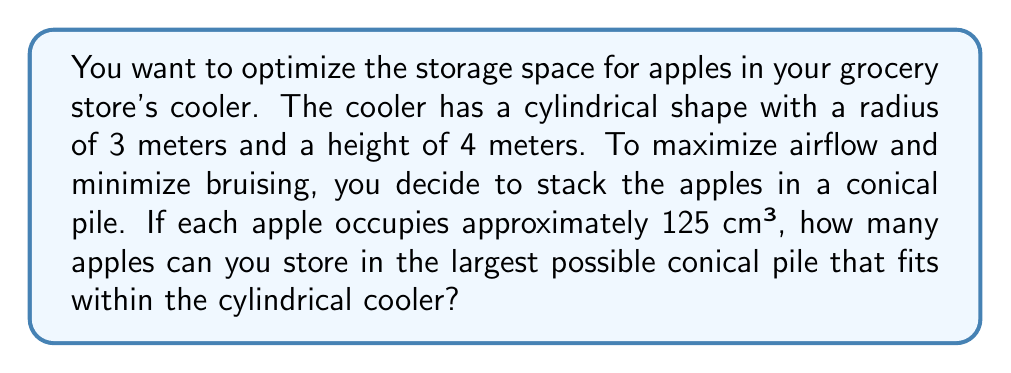Teach me how to tackle this problem. Let's approach this step-by-step:

1) First, we need to determine the dimensions of the largest cone that fits inside the cylinder. The cone's base radius will be equal to the cylinder's radius (3 m), and its height will be equal to the cylinder's height (4 m).

2) The volume of a cone is given by the formula:

   $$V_{cone} = \frac{1}{3}\pi r^2 h$$

   where $r$ is the radius of the base and $h$ is the height.

3) Substituting our values:

   $$V_{cone} = \frac{1}{3}\pi (3\,m)^2 (4\,m) = \frac{4}{3}\pi (9\,m^3) = 12\pi\,m^3$$

4) We need to convert this to cm³:

   $$12\pi\,m^3 = 12\pi \times (100\,cm)^3 = 12,000,000\pi\,cm^3$$

5) Now, we divide this volume by the volume of each apple (125 cm³):

   $$\text{Number of apples} = \frac{12,000,000\pi\,cm^3}{125\,cm^3} = 96,000\pi$$

6) Since we can't have a fractional apple, we need to round down to the nearest whole number:

   $$\text{Number of apples} = \lfloor 96,000\pi \rfloor = 301,593$$

Therefore, you can store 301,593 apples in the largest conical pile that fits within your cylindrical cooler.
Answer: 301,593 apples 